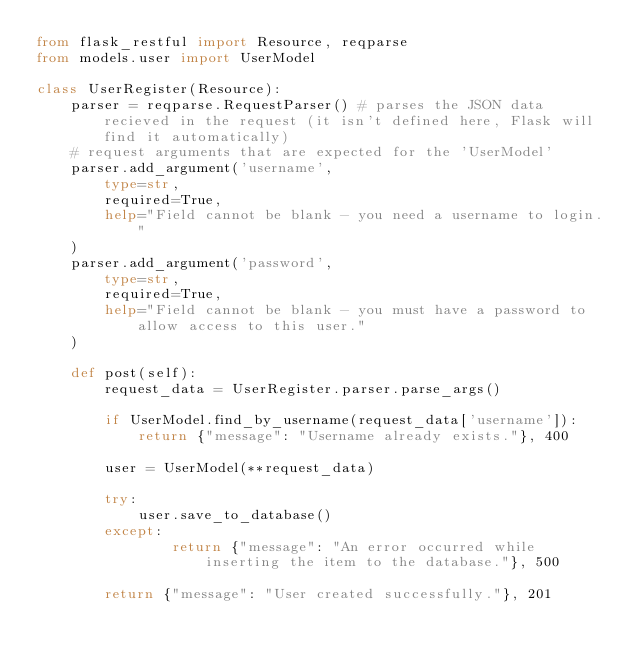<code> <loc_0><loc_0><loc_500><loc_500><_Python_>from flask_restful import Resource, reqparse
from models.user import UserModel

class UserRegister(Resource):
    parser = reqparse.RequestParser() # parses the JSON data recieved in the request (it isn't defined here, Flask will find it automatically)
    # request arguments that are expected for the 'UserModel'
    parser.add_argument('username',
        type=str,
        required=True,
        help="Field cannot be blank - you need a username to login."
    )
    parser.add_argument('password',
        type=str,
        required=True,
        help="Field cannot be blank - you must have a password to allow access to this user."
    )

    def post(self):
        request_data = UserRegister.parser.parse_args()

        if UserModel.find_by_username(request_data['username']):
            return {"message": "Username already exists."}, 400

        user = UserModel(**request_data)

        try:
            user.save_to_database()
        except:
                return {"message": "An error occurred while inserting the item to the database."}, 500

        return {"message": "User created successfully."}, 201
</code> 